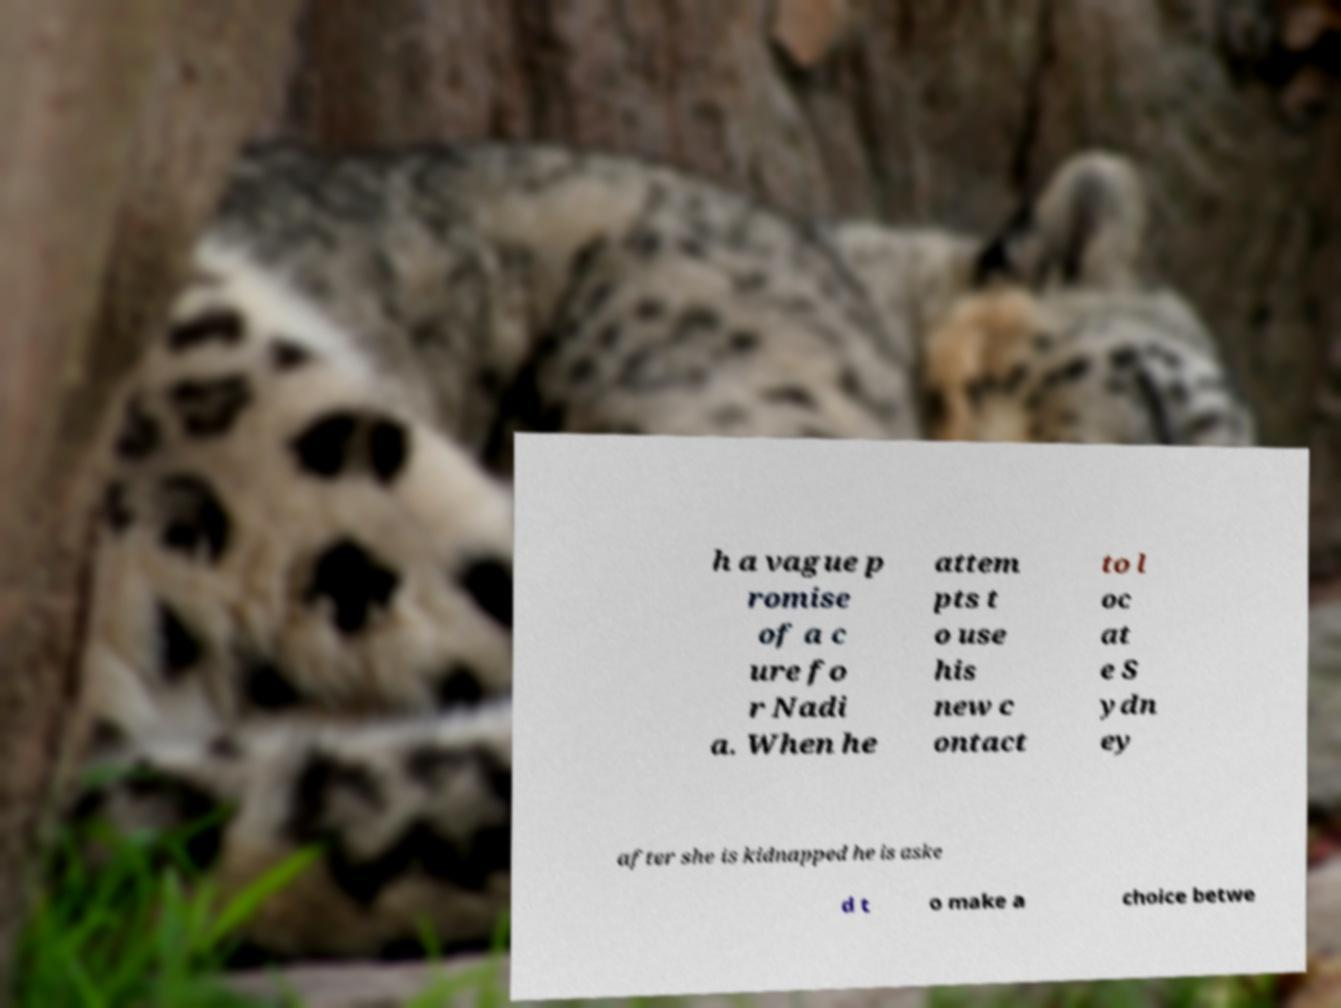Could you assist in decoding the text presented in this image and type it out clearly? h a vague p romise of a c ure fo r Nadi a. When he attem pts t o use his new c ontact to l oc at e S ydn ey after she is kidnapped he is aske d t o make a choice betwe 